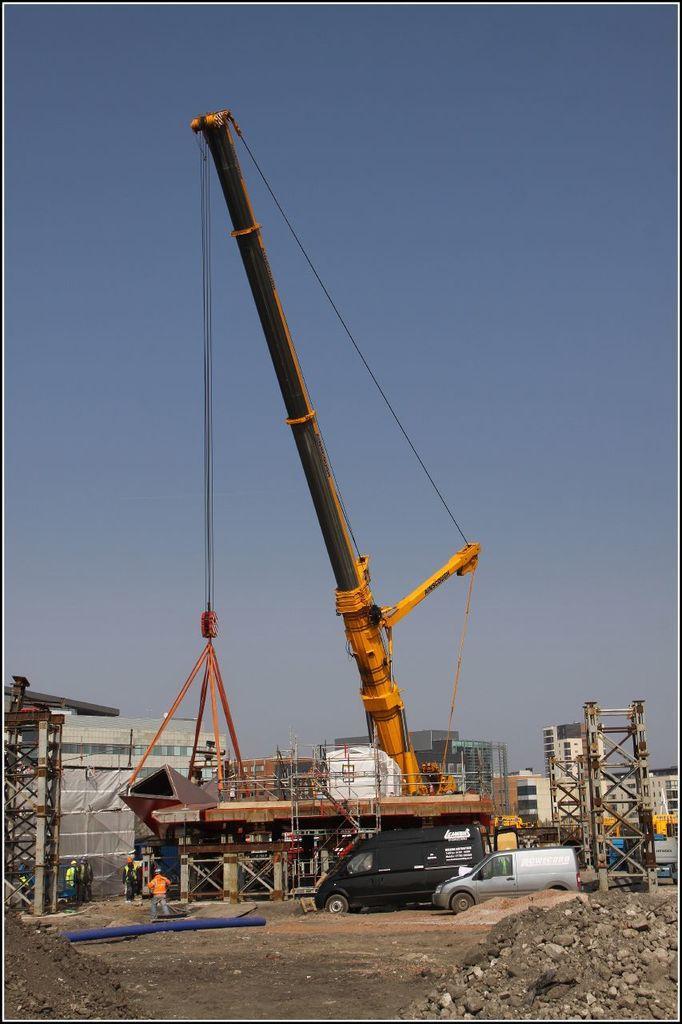Describe this image in one or two sentences. In this image in the center there are some vehicles, poles, towers and some buildings and there are some iron rods. And at the bottom there is sand and some stones and there are people and objects, at the top there is sky. 